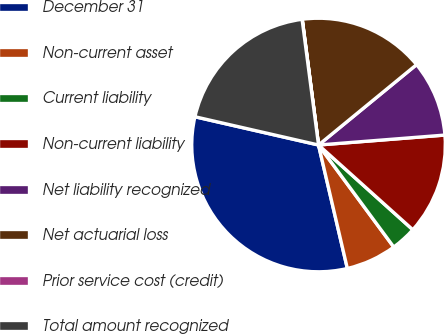<chart> <loc_0><loc_0><loc_500><loc_500><pie_chart><fcel>December 31<fcel>Non-current asset<fcel>Current liability<fcel>Non-current liability<fcel>Net liability recognized<fcel>Net actuarial loss<fcel>Prior service cost (credit)<fcel>Total amount recognized<nl><fcel>32.23%<fcel>6.46%<fcel>3.24%<fcel>12.9%<fcel>9.68%<fcel>16.12%<fcel>0.02%<fcel>19.35%<nl></chart> 